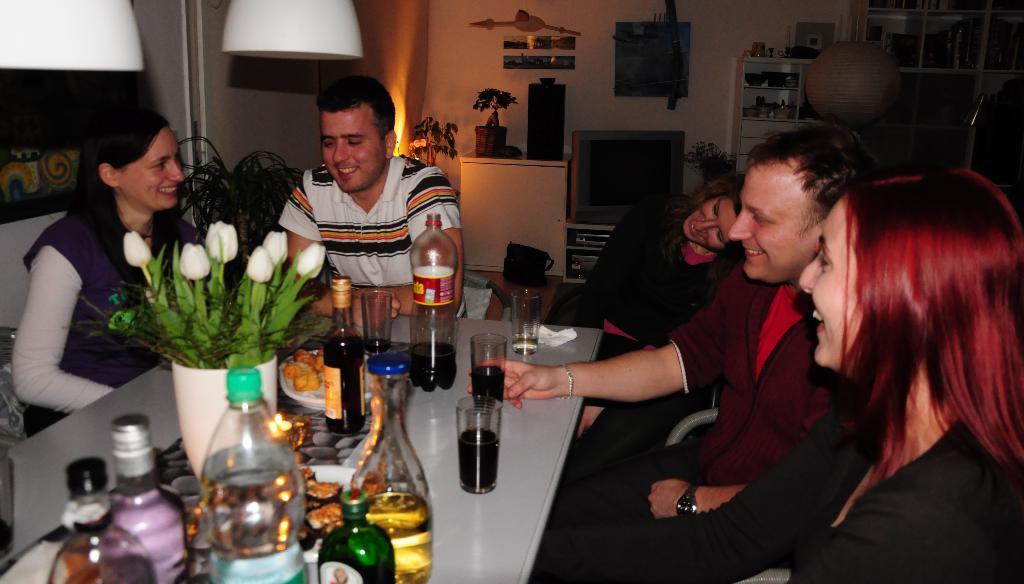Can you describe this image briefly? In this picture I can see 2 men and 3 women sitting on chairs and I can see a table in front, on which there are glasses and bottles and I can also see few flowers. In the background I can see few plants, a TV and many things on the racks. On the top left corner of this picture I can see 2 white color things. 